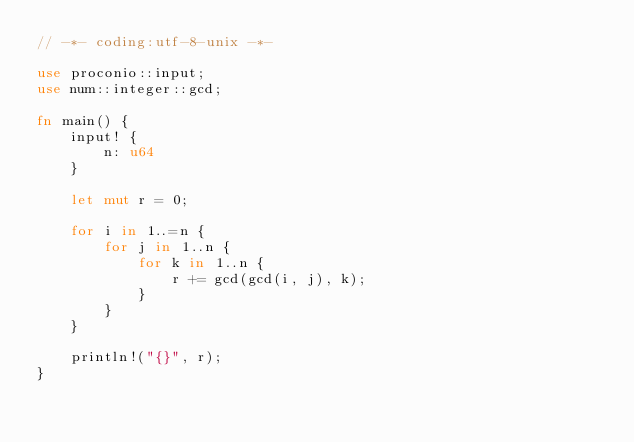Convert code to text. <code><loc_0><loc_0><loc_500><loc_500><_Rust_>// -*- coding:utf-8-unix -*-

use proconio::input;
use num::integer::gcd;

fn main() {
    input! {
        n: u64
    }

    let mut r = 0;

    for i in 1..=n {
        for j in 1..n {
            for k in 1..n {
                r += gcd(gcd(i, j), k);
            }
        }
    }

    println!("{}", r);
}
</code> 